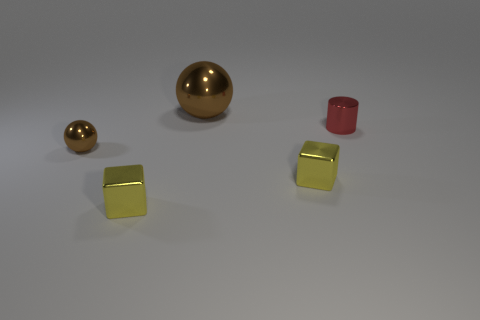The brown thing that is the same size as the cylinder is what shape? sphere 